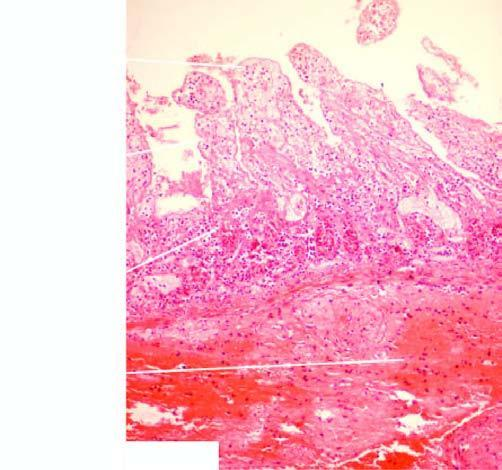s inflammatory cell infiltration marked at the line of demarcation between the infarcted and normal bowel?
Answer the question using a single word or phrase. Yes 